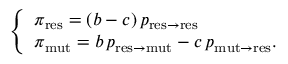<formula> <loc_0><loc_0><loc_500><loc_500>\left \{ \begin{array} { l l } { \pi _ { r e s } = ( b - c ) \, p _ { r e s \to r e s } } \\ { \pi _ { m u t } = b \, p _ { r e s \to m u t } - c \, p _ { m u t \to r e s } . } \end{array}</formula> 